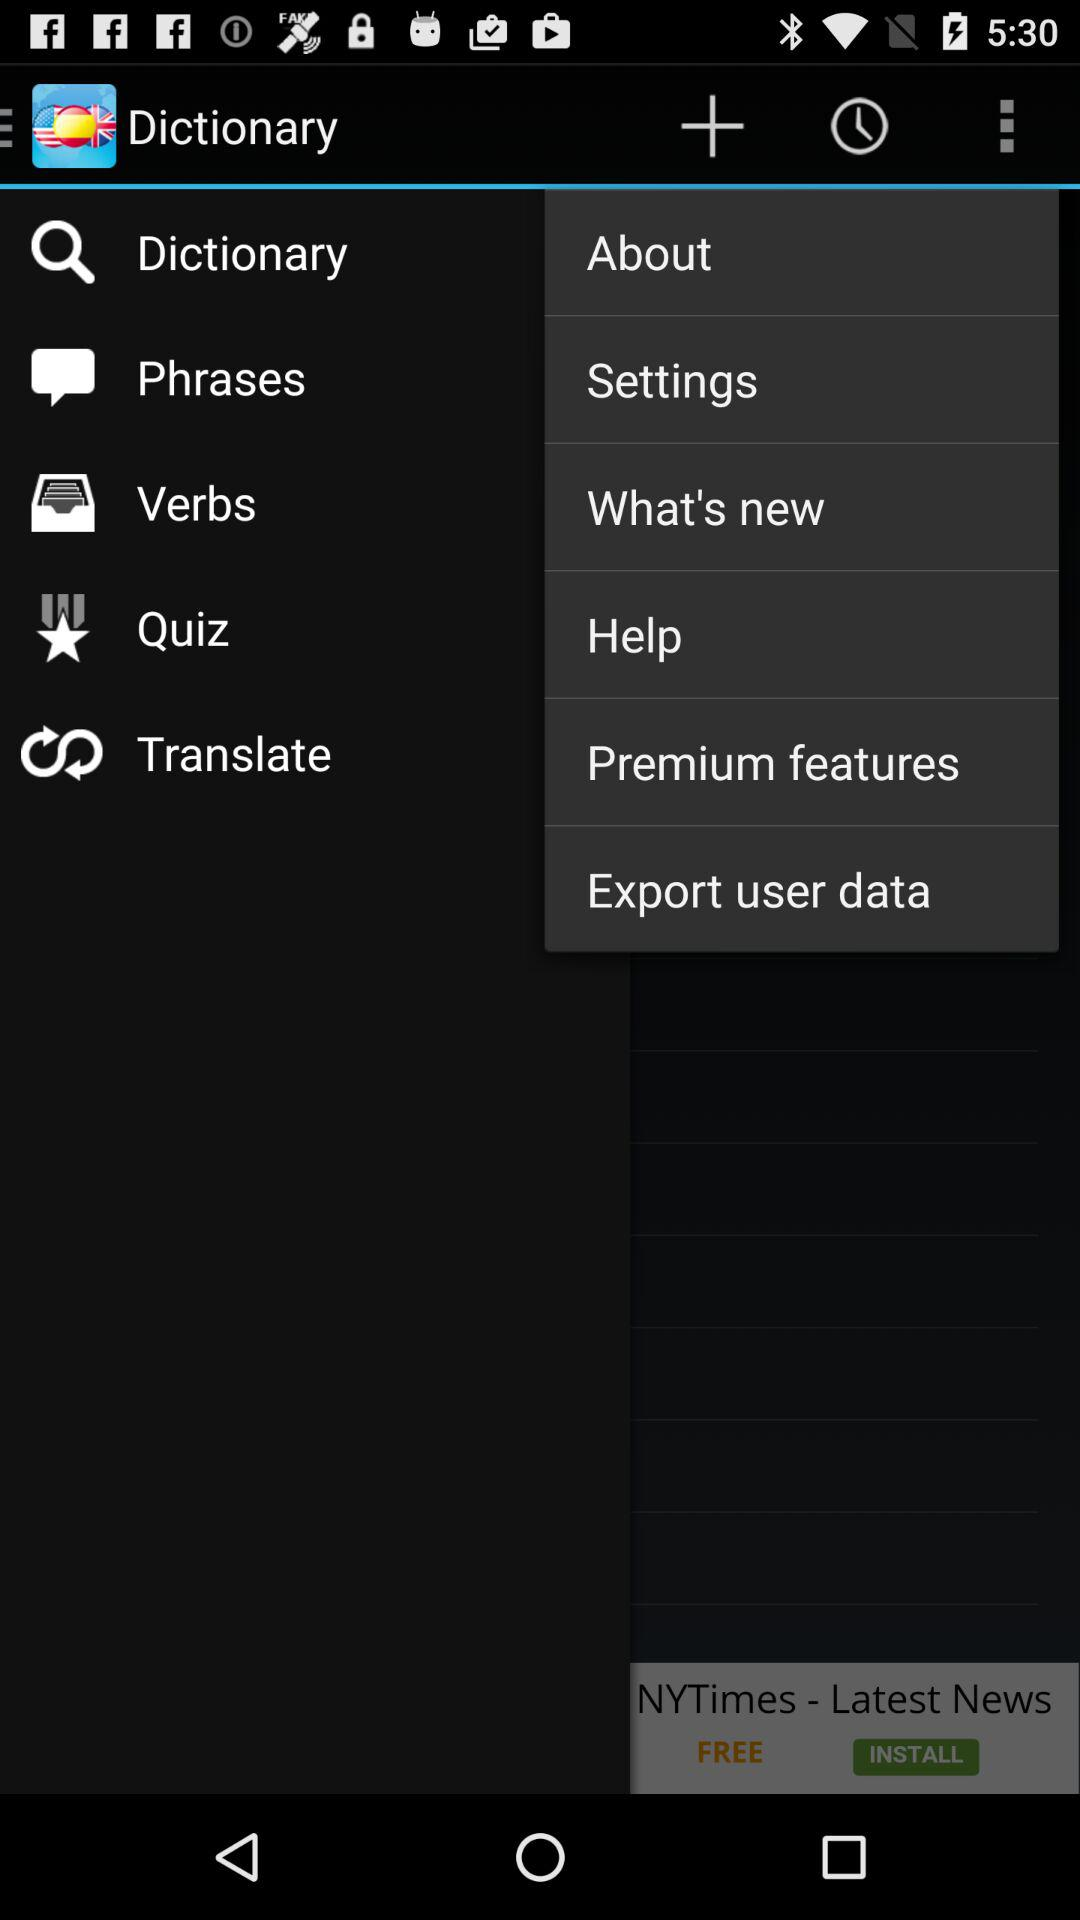What is the app name? The app name is "Dictionary". 